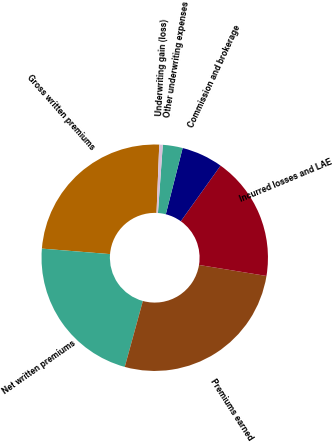Convert chart to OTSL. <chart><loc_0><loc_0><loc_500><loc_500><pie_chart><fcel>Gross written premiums<fcel>Net written premiums<fcel>Premiums earned<fcel>Incurred losses and LAE<fcel>Commission and brokerage<fcel>Other underwriting expenses<fcel>Underwriting gain (loss)<nl><fcel>24.35%<fcel>22.02%<fcel>26.69%<fcel>17.7%<fcel>5.91%<fcel>2.83%<fcel>0.5%<nl></chart> 